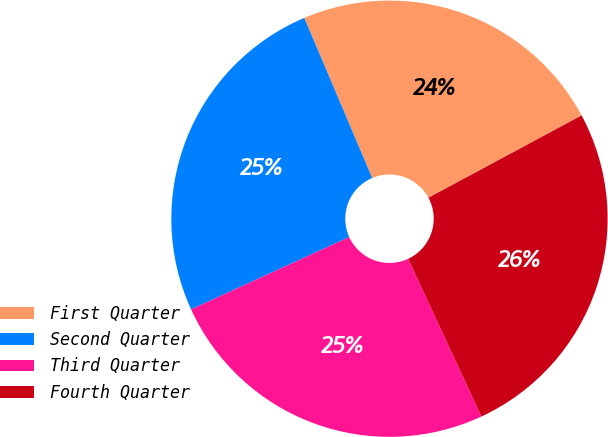Convert chart to OTSL. <chart><loc_0><loc_0><loc_500><loc_500><pie_chart><fcel>First Quarter<fcel>Second Quarter<fcel>Third Quarter<fcel>Fourth Quarter<nl><fcel>23.54%<fcel>25.44%<fcel>25.1%<fcel>25.93%<nl></chart> 